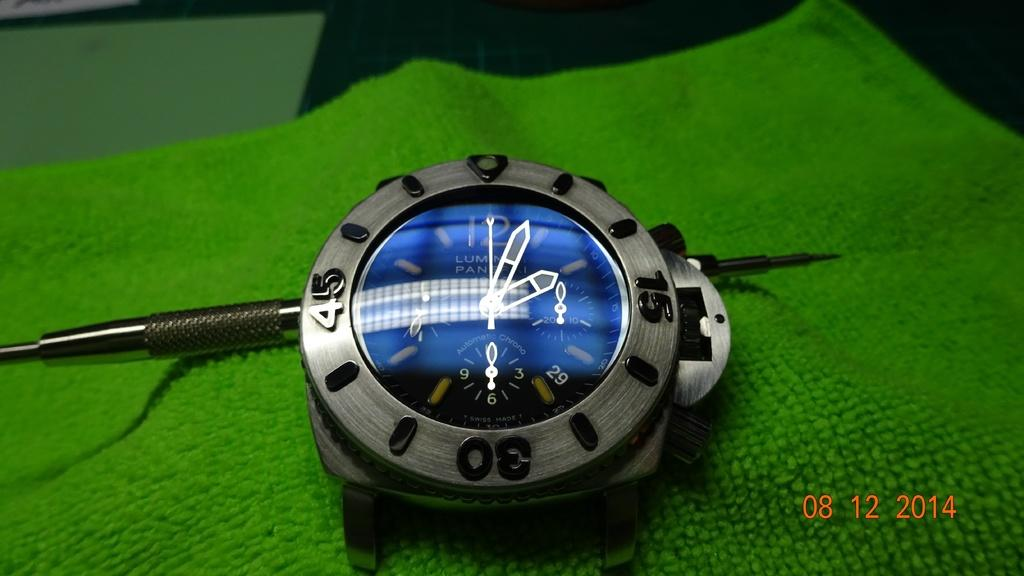<image>
Present a compact description of the photo's key features. The time shown on the watch face is about 2:04 